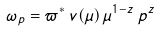<formula> <loc_0><loc_0><loc_500><loc_500>\omega _ { p } = \varpi ^ { * } \, v ( \mu ) \, \mu ^ { 1 - z } \, p ^ { z }</formula> 